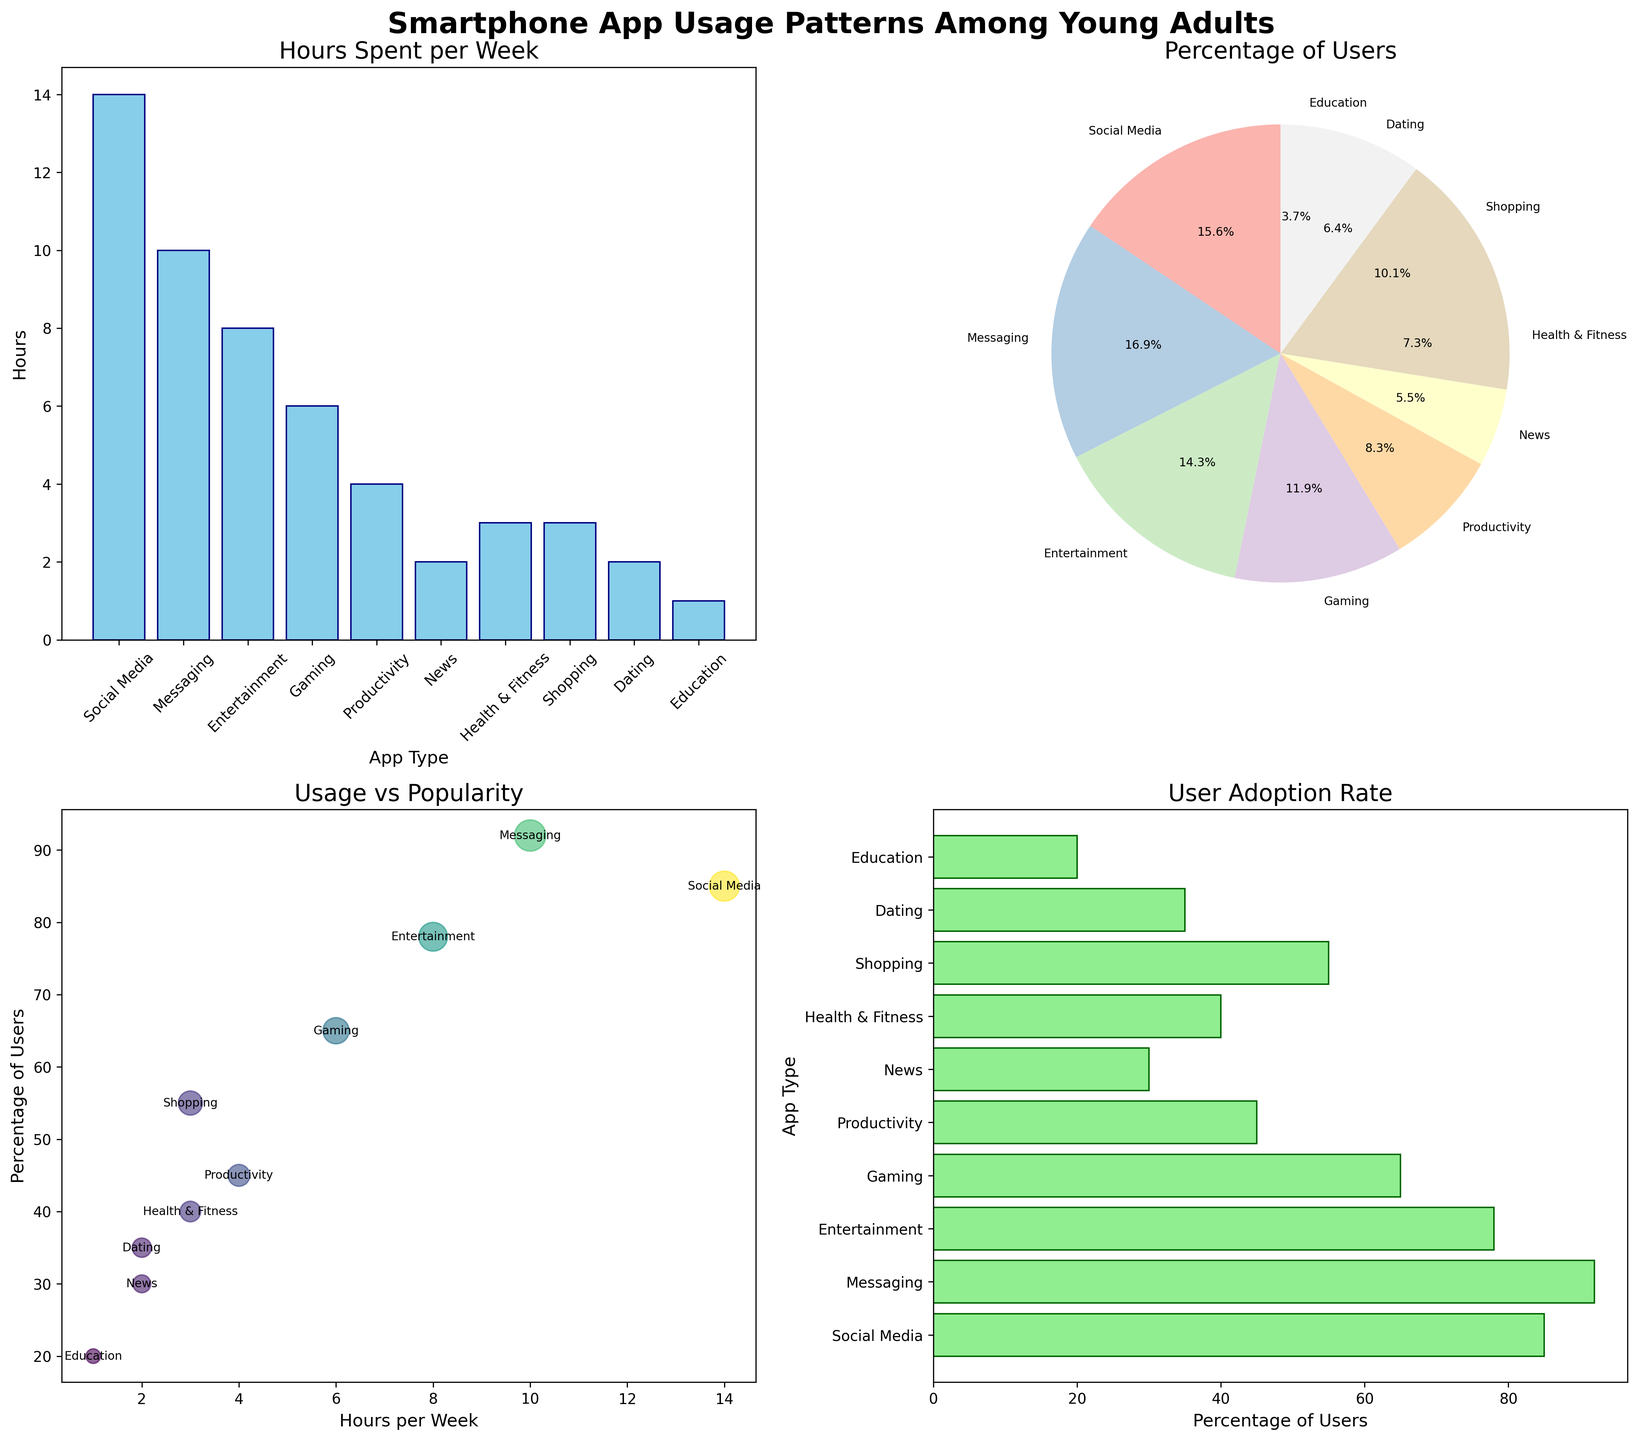how many hours per week are spent on social media apps? The subplot with the bar chart titled "Hours Spent per Week" shows that Social Media apps have a bar extending to 14 hours.
Answer: 14 hours which app type has the highest adoption rate? The horizontal bar chart titled "User Adoption Rate" shows the highest percentage of users for Messaging apps at 92%.
Answer: Messaging how does the usage of health & fitness apps compare to productivity apps? In the bar chart, Health & Fitness apps show 3 hours per week while Productivity shows 4 hours per week. In the horizontal bar chart, Health & Fitness at 40% and Productivity at 45%.
Answer: Productivity apps are used 1 hour more per week and have 5% more users what app type has both the lowest usage hours and user percentage? The bar chart indicates that Education apps have the lowest usage at 1 hour per week, and the horizontal bar chart confirms Education apps also have the lowest user percentage at 20%.
Answer: Education which three app types have the most similar user percentages? Observing the pie chart and the horizontal bar chart, Dating (35%), Health & Fitness (40%), and Productivity (45%) have a similar user base.
Answer: Dating, Health & Fitness, and Productivity how does the percentage of social media users compare to the percentage of gaming app users? The horizontal bar chart shows Social Media apps with 85% users, and Gaming apps with 65%.
Answer: Social Media has 20% more users what is the average number of hours spent on Entertainment and Gaming apps? Entertainment has 8 hours and Gaming has 6 hours per week. The average is (8+6)/2 = 7 hours.
Answer: 7 hours which app type is used by more than 90% of users? According to the pie chart, Messaging apps are used by 92% of users.
Answer: Messaging what app is used for 4 hours per week and what is the percentage of its users? The bar chart shows that Productivity apps are used for 4 hours per week. The horizontal bar chart indicates 45% of user adoption.
Answer: Productivity, 45% what are the top three app types in terms of hours spent per week? The bar chart shows the top three are Social Media (14 hours), Messaging (10 hours), and Entertainment (8 hours).
Answer: Social Media, Messaging, Entertainment 